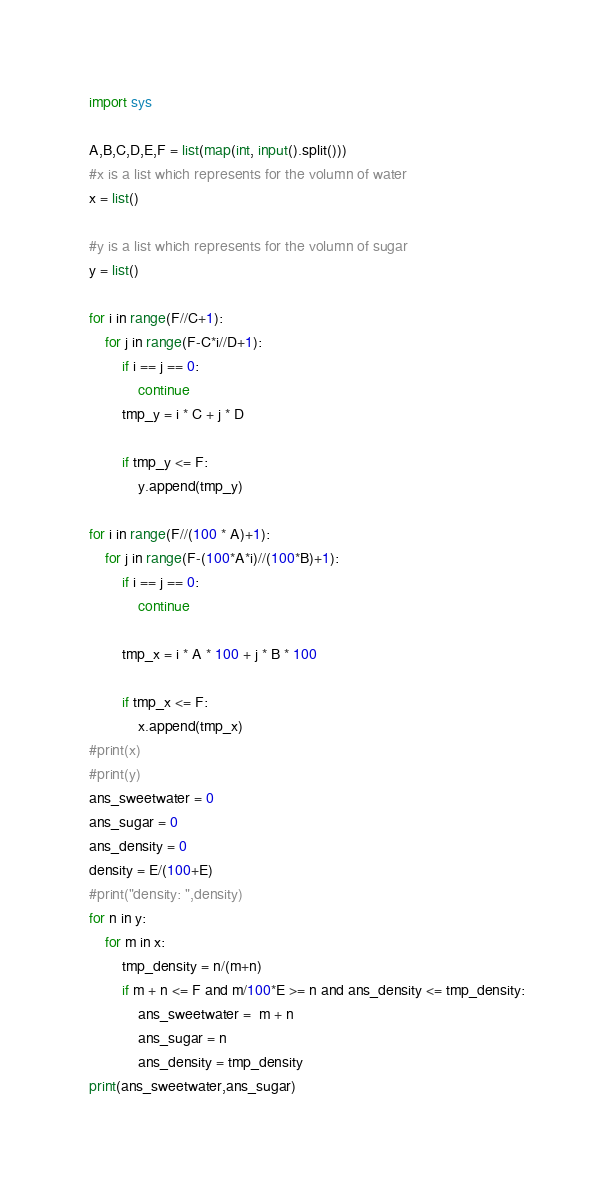<code> <loc_0><loc_0><loc_500><loc_500><_Python_>import sys

A,B,C,D,E,F = list(map(int, input().split()))
#x is a list which represents for the volumn of water
x = list()

#y is a list which represents for the volumn of sugar
y = list()

for i in range(F//C+1):
    for j in range(F-C*i//D+1):
        if i == j == 0:
            continue
        tmp_y = i * C + j * D

        if tmp_y <= F:
            y.append(tmp_y)

for i in range(F//(100 * A)+1):
    for j in range(F-(100*A*i)//(100*B)+1):
        if i == j == 0:
            continue

        tmp_x = i * A * 100 + j * B * 100

        if tmp_x <= F:
            x.append(tmp_x)
#print(x)
#print(y)
ans_sweetwater = 0
ans_sugar = 0
ans_density = 0
density = E/(100+E)
#print("density: ",density)
for n in y:
    for m in x:
        tmp_density = n/(m+n)
        if m + n <= F and m/100*E >= n and ans_density <= tmp_density:
            ans_sweetwater =  m + n
            ans_sugar = n
            ans_density = tmp_density
print(ans_sweetwater,ans_sugar)
</code> 